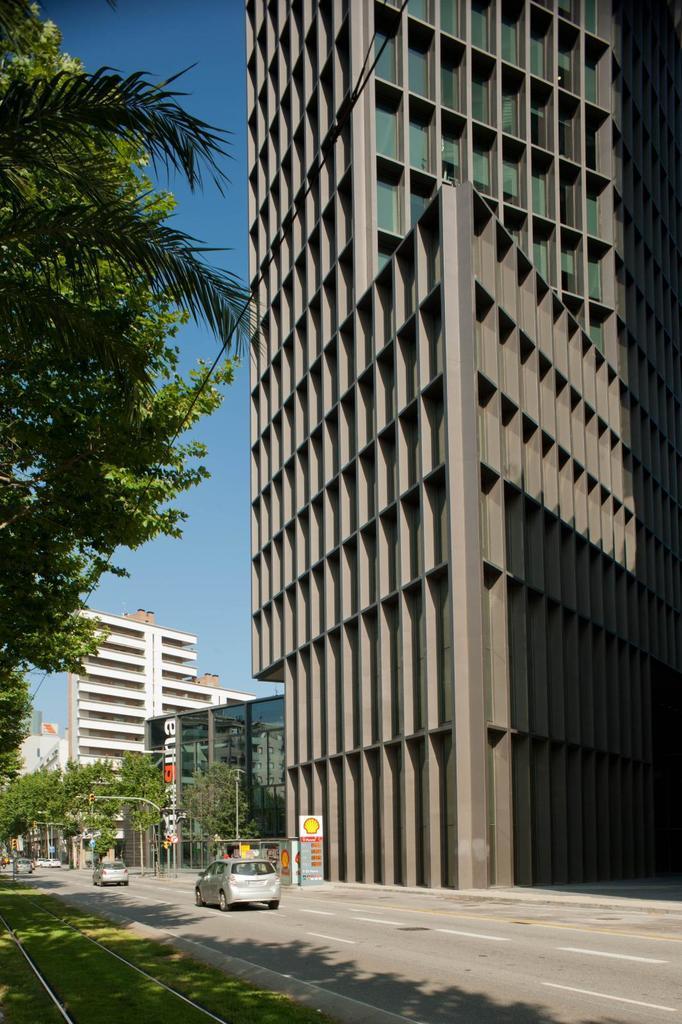How would you summarize this image in a sentence or two? This image is taken outdoors. At the bottom of the image there is a road and there is a ground with grass on it and there is a track. At the top of the image there is a sky. On the left side of the image there are a few trees. In the middle of the image there are a few buildings and there is a skyscraper. There are a few trees and poles. There are a few boards with text on them and two cars are moving on the road. 